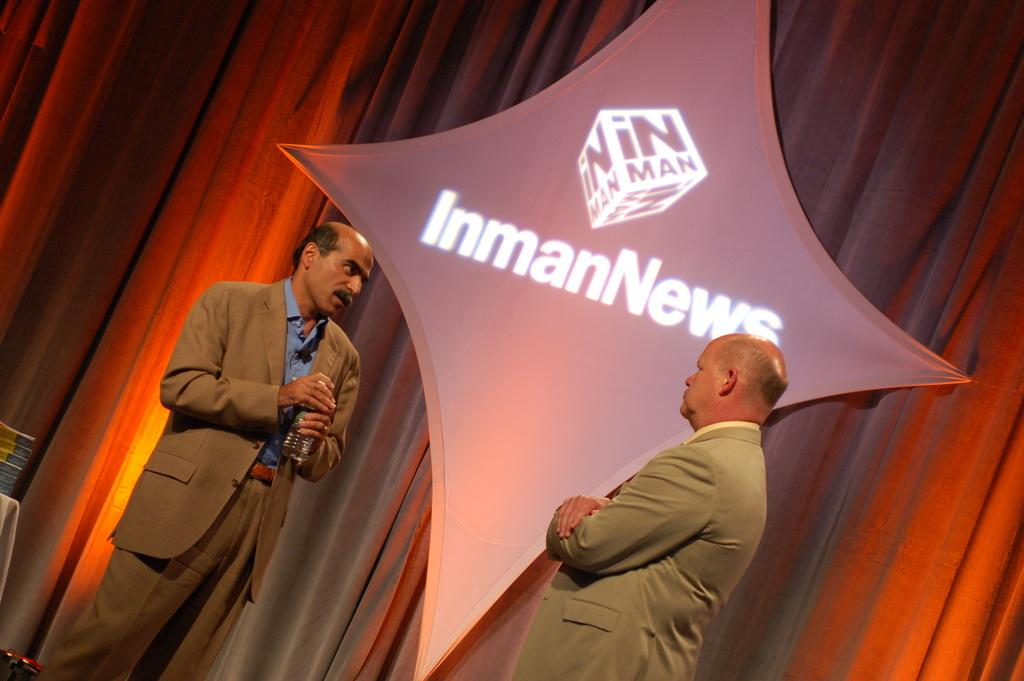What is the position of the man in the image? There is a man standing at the bottom of the image. Can you describe the man in the bottom right corner of the image? There is a man standing in the bottom right corner of the image, holding a bottle. What type of material is visible in the image? There is cloth visible in the image. What is hanging in the image? There is a banner visible in the image. What shape is the bear in the image? There is no bear present in the image. What thought is the man in the image having? The image does not provide any information about the man's thoughts. 